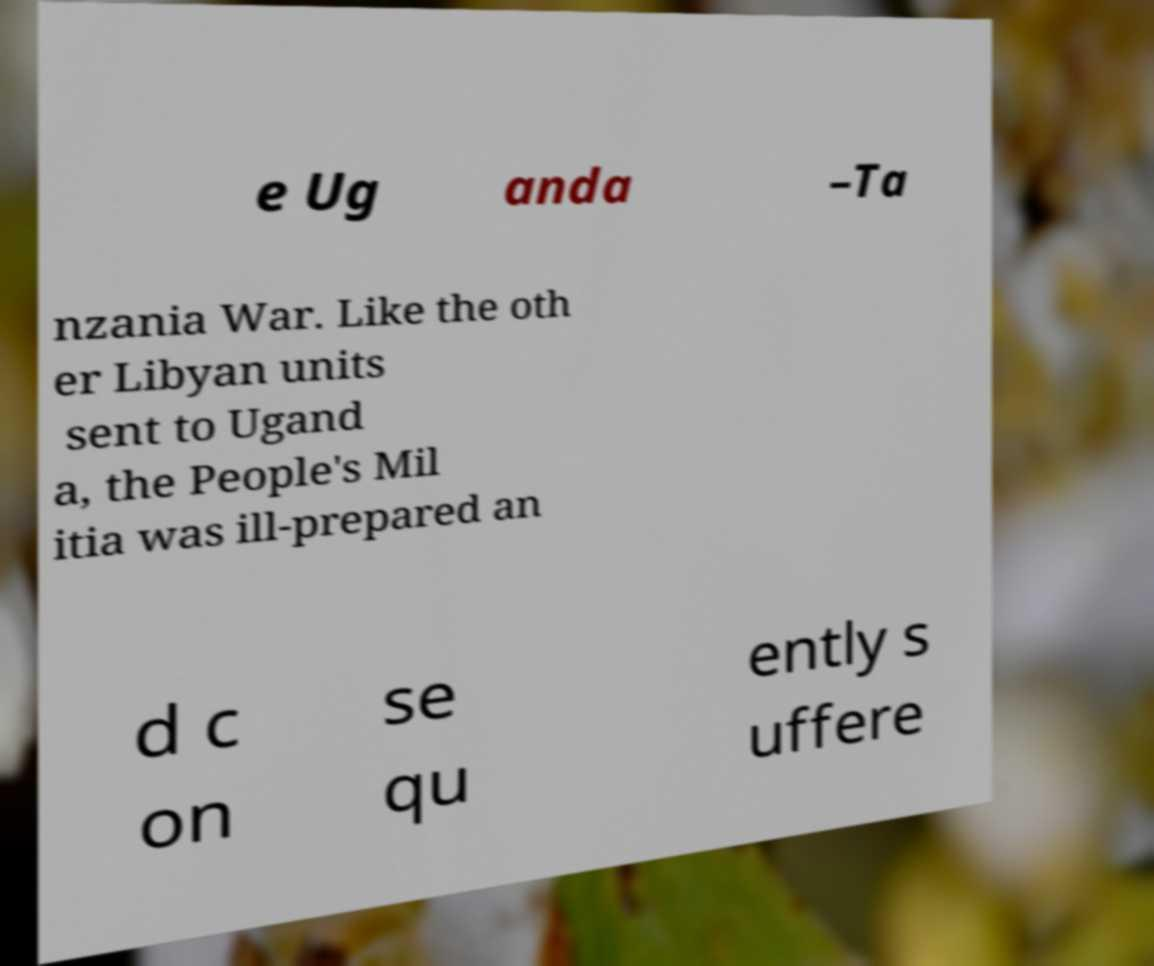Please identify and transcribe the text found in this image. e Ug anda –Ta nzania War. Like the oth er Libyan units sent to Ugand a, the People's Mil itia was ill-prepared an d c on se qu ently s uffere 